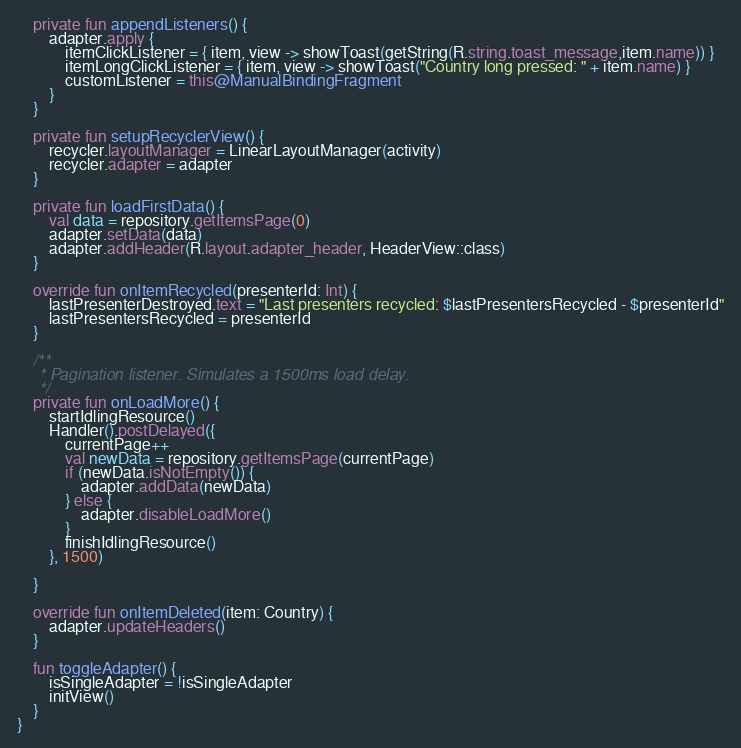<code> <loc_0><loc_0><loc_500><loc_500><_Kotlin_>    private fun appendListeners() {
        adapter.apply {
            itemClickListener = { item, view -> showToast(getString(R.string.toast_message,item.name)) }
            itemLongClickListener = { item, view -> showToast("Country long pressed: " + item.name) }
            customListener = this@ManualBindingFragment
        }
    }

    private fun setupRecyclerView() {
        recycler.layoutManager = LinearLayoutManager(activity)
        recycler.adapter = adapter
    }

    private fun loadFirstData() {
        val data = repository.getItemsPage(0)
        adapter.setData(data)
        adapter.addHeader(R.layout.adapter_header, HeaderView::class)
    }

    override fun onItemRecycled(presenterId: Int) {
        lastPresenterDestroyed.text = "Last presenters recycled: $lastPresentersRecycled - $presenterId"
        lastPresentersRecycled = presenterId
    }

    /**
     * Pagination listener. Simulates a 1500ms load delay.
     */
    private fun onLoadMore() {
        startIdlingResource()
        Handler().postDelayed({
            currentPage++
            val newData = repository.getItemsPage(currentPage)
            if (newData.isNotEmpty()) {
                adapter.addData(newData)
            } else {
                adapter.disableLoadMore()
            }
            finishIdlingResource()
        }, 1500)

    }

    override fun onItemDeleted(item: Country) {
        adapter.updateHeaders()
    }

    fun toggleAdapter() {
        isSingleAdapter = !isSingleAdapter
        initView()
    }
}

</code> 